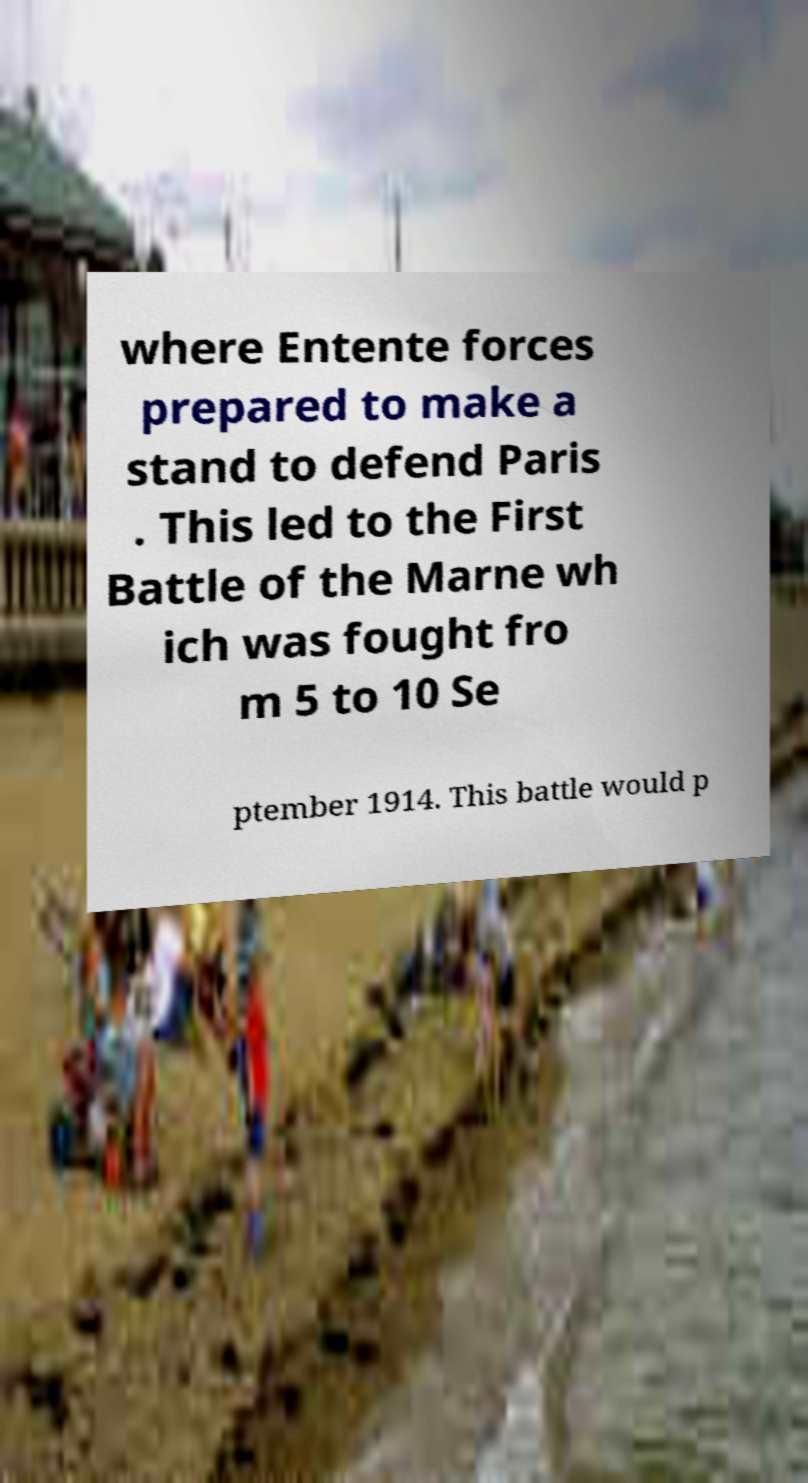Could you extract and type out the text from this image? where Entente forces prepared to make a stand to defend Paris . This led to the First Battle of the Marne wh ich was fought fro m 5 to 10 Se ptember 1914. This battle would p 